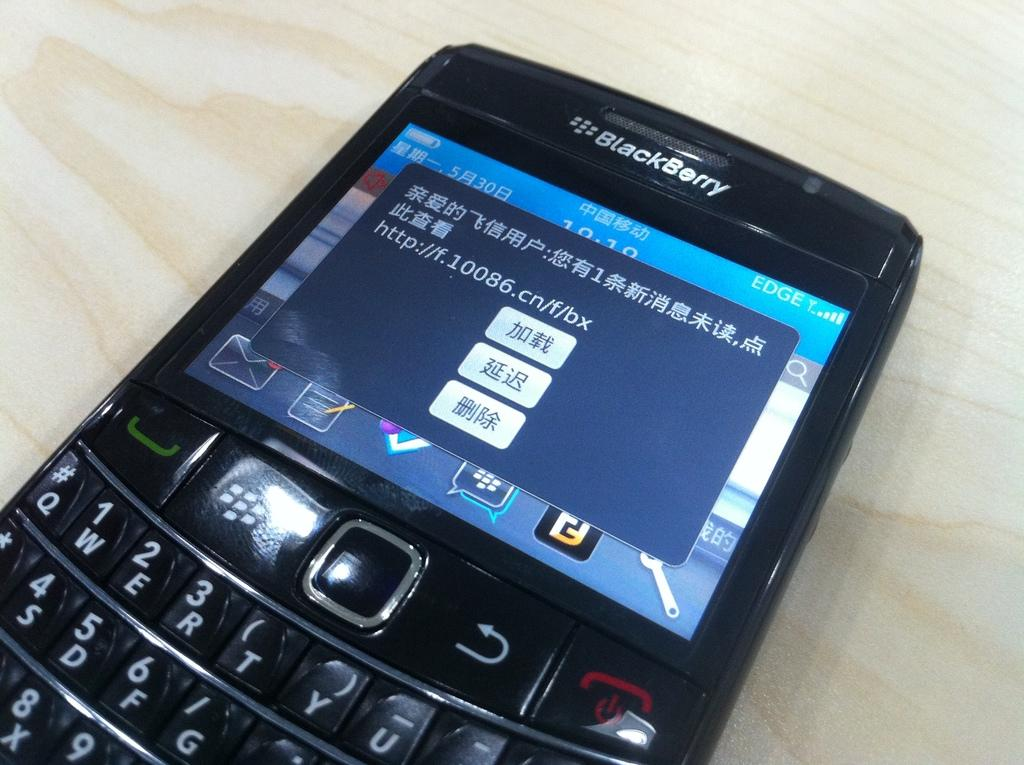What object is hanging in the image? There is a mobile in the image. What can be observed about the surface beneath the mobile? The surface beneath the mobile is cream and brown in color. How many spiders are crawling on the mobile in the image? There are no spiders present in the image; it only features a mobile. Is there a spy observing the mobile in the image? There is no indication of a spy or any person in the image; it only features a mobile and a colored surface beneath it. 